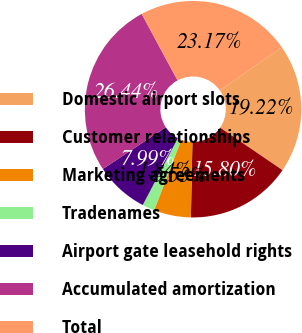Convert chart. <chart><loc_0><loc_0><loc_500><loc_500><pie_chart><fcel>Domestic airport slots<fcel>Customer relationships<fcel>Marketing agreements<fcel>Tradenames<fcel>Airport gate leasehold rights<fcel>Accumulated amortization<fcel>Total<nl><fcel>19.22%<fcel>15.8%<fcel>5.53%<fcel>1.84%<fcel>7.99%<fcel>26.44%<fcel>23.17%<nl></chart> 